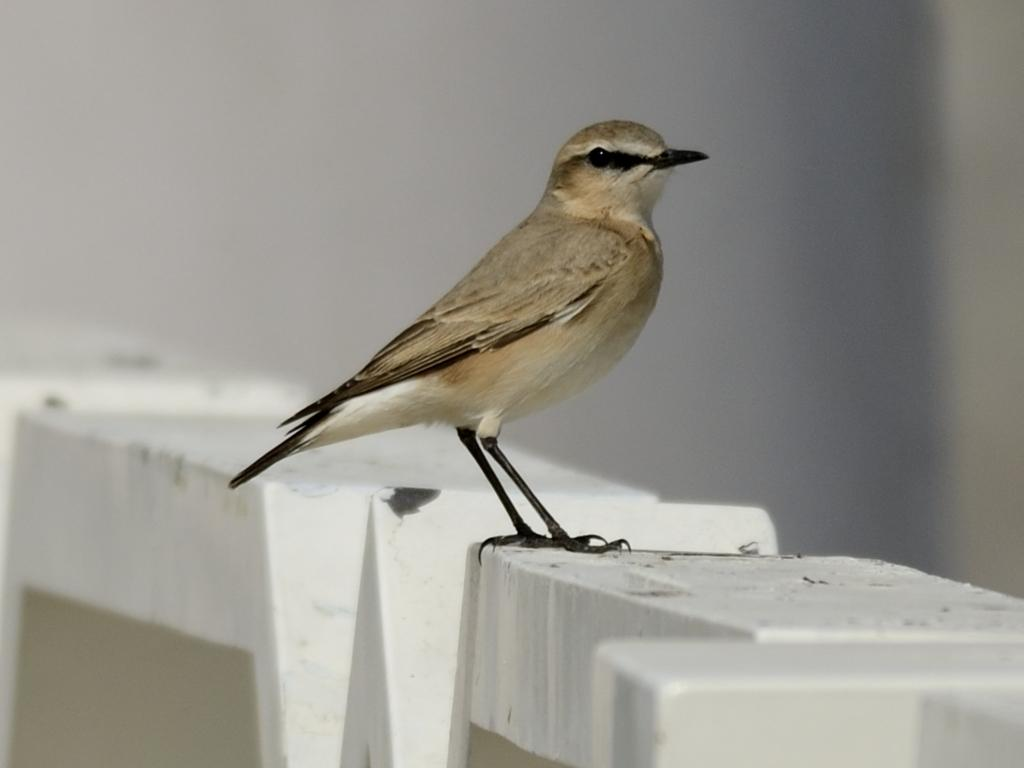What type of animal can be seen in the image? There is a bird in the image. What type of card is the turkey holding in the image? There is no turkey or card present in the image; it features a bird. What sound does the bell make when the bird rings it in the image? There is no bell present in the image; it features a bird. 